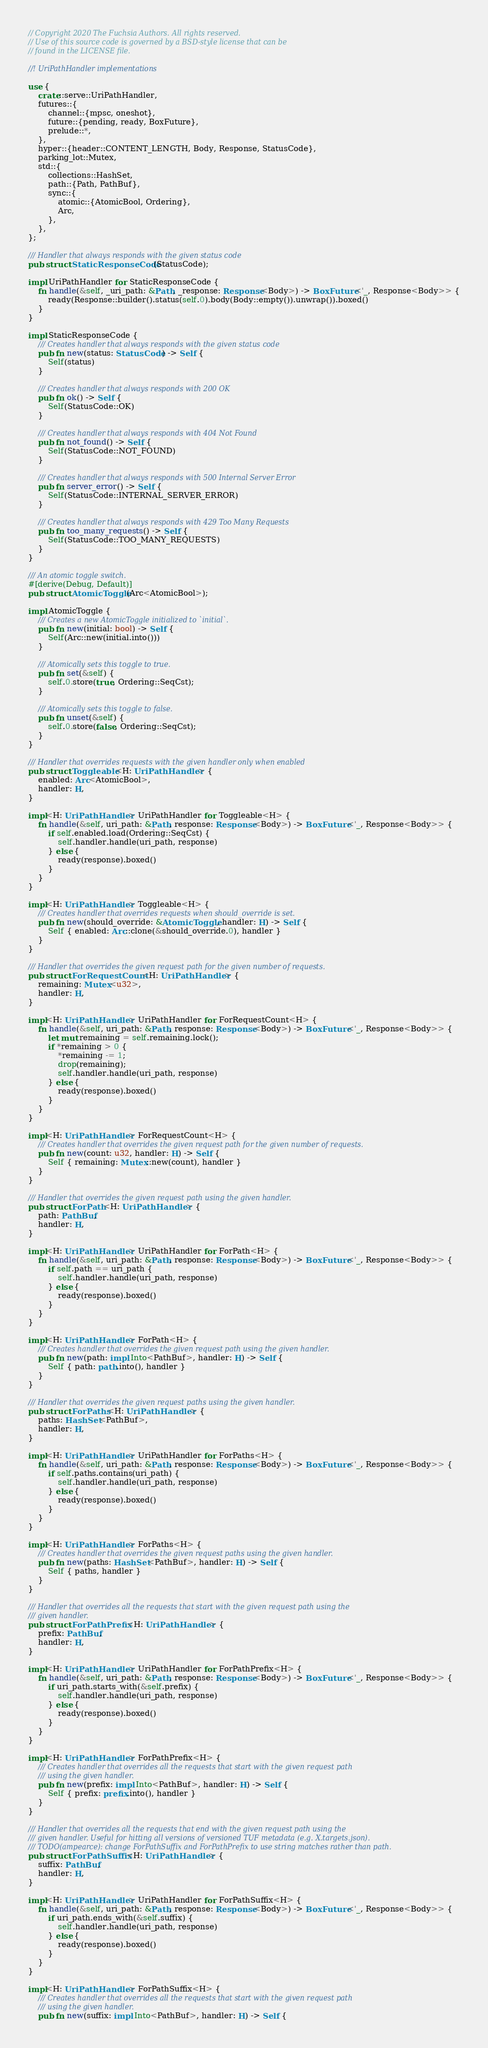Convert code to text. <code><loc_0><loc_0><loc_500><loc_500><_Rust_>// Copyright 2020 The Fuchsia Authors. All rights reserved.
// Use of this source code is governed by a BSD-style license that can be
// found in the LICENSE file.

//! UriPathHandler implementations

use {
    crate::serve::UriPathHandler,
    futures::{
        channel::{mpsc, oneshot},
        future::{pending, ready, BoxFuture},
        prelude::*,
    },
    hyper::{header::CONTENT_LENGTH, Body, Response, StatusCode},
    parking_lot::Mutex,
    std::{
        collections::HashSet,
        path::{Path, PathBuf},
        sync::{
            atomic::{AtomicBool, Ordering},
            Arc,
        },
    },
};

/// Handler that always responds with the given status code
pub struct StaticResponseCode(StatusCode);

impl UriPathHandler for StaticResponseCode {
    fn handle(&self, _uri_path: &Path, _response: Response<Body>) -> BoxFuture<'_, Response<Body>> {
        ready(Response::builder().status(self.0).body(Body::empty()).unwrap()).boxed()
    }
}

impl StaticResponseCode {
    /// Creates handler that always responds with the given status code
    pub fn new(status: StatusCode) -> Self {
        Self(status)
    }

    /// Creates handler that always responds with 200 OK
    pub fn ok() -> Self {
        Self(StatusCode::OK)
    }

    /// Creates handler that always responds with 404 Not Found
    pub fn not_found() -> Self {
        Self(StatusCode::NOT_FOUND)
    }

    /// Creates handler that always responds with 500 Internal Server Error
    pub fn server_error() -> Self {
        Self(StatusCode::INTERNAL_SERVER_ERROR)
    }

    /// Creates handler that always responds with 429 Too Many Requests
    pub fn too_many_requests() -> Self {
        Self(StatusCode::TOO_MANY_REQUESTS)
    }
}

/// An atomic toggle switch.
#[derive(Debug, Default)]
pub struct AtomicToggle(Arc<AtomicBool>);

impl AtomicToggle {
    /// Creates a new AtomicToggle initialized to `initial`.
    pub fn new(initial: bool) -> Self {
        Self(Arc::new(initial.into()))
    }

    /// Atomically sets this toggle to true.
    pub fn set(&self) {
        self.0.store(true, Ordering::SeqCst);
    }

    /// Atomically sets this toggle to false.
    pub fn unset(&self) {
        self.0.store(false, Ordering::SeqCst);
    }
}

/// Handler that overrides requests with the given handler only when enabled
pub struct Toggleable<H: UriPathHandler> {
    enabled: Arc<AtomicBool>,
    handler: H,
}

impl<H: UriPathHandler> UriPathHandler for Toggleable<H> {
    fn handle(&self, uri_path: &Path, response: Response<Body>) -> BoxFuture<'_, Response<Body>> {
        if self.enabled.load(Ordering::SeqCst) {
            self.handler.handle(uri_path, response)
        } else {
            ready(response).boxed()
        }
    }
}

impl<H: UriPathHandler> Toggleable<H> {
    /// Creates handler that overrides requests when should_override is set.
    pub fn new(should_override: &AtomicToggle, handler: H) -> Self {
        Self { enabled: Arc::clone(&should_override.0), handler }
    }
}

/// Handler that overrides the given request path for the given number of requests.
pub struct ForRequestCount<H: UriPathHandler> {
    remaining: Mutex<u32>,
    handler: H,
}

impl<H: UriPathHandler> UriPathHandler for ForRequestCount<H> {
    fn handle(&self, uri_path: &Path, response: Response<Body>) -> BoxFuture<'_, Response<Body>> {
        let mut remaining = self.remaining.lock();
        if *remaining > 0 {
            *remaining -= 1;
            drop(remaining);
            self.handler.handle(uri_path, response)
        } else {
            ready(response).boxed()
        }
    }
}

impl<H: UriPathHandler> ForRequestCount<H> {
    /// Creates handler that overrides the given request path for the given number of requests.
    pub fn new(count: u32, handler: H) -> Self {
        Self { remaining: Mutex::new(count), handler }
    }
}

/// Handler that overrides the given request path using the given handler.
pub struct ForPath<H: UriPathHandler> {
    path: PathBuf,
    handler: H,
}

impl<H: UriPathHandler> UriPathHandler for ForPath<H> {
    fn handle(&self, uri_path: &Path, response: Response<Body>) -> BoxFuture<'_, Response<Body>> {
        if self.path == uri_path {
            self.handler.handle(uri_path, response)
        } else {
            ready(response).boxed()
        }
    }
}

impl<H: UriPathHandler> ForPath<H> {
    /// Creates handler that overrides the given request path using the given handler.
    pub fn new(path: impl Into<PathBuf>, handler: H) -> Self {
        Self { path: path.into(), handler }
    }
}

/// Handler that overrides the given request paths using the given handler.
pub struct ForPaths<H: UriPathHandler> {
    paths: HashSet<PathBuf>,
    handler: H,
}

impl<H: UriPathHandler> UriPathHandler for ForPaths<H> {
    fn handle(&self, uri_path: &Path, response: Response<Body>) -> BoxFuture<'_, Response<Body>> {
        if self.paths.contains(uri_path) {
            self.handler.handle(uri_path, response)
        } else {
            ready(response).boxed()
        }
    }
}

impl<H: UriPathHandler> ForPaths<H> {
    /// Creates handler that overrides the given request paths using the given handler.
    pub fn new(paths: HashSet<PathBuf>, handler: H) -> Self {
        Self { paths, handler }
    }
}

/// Handler that overrides all the requests that start with the given request path using the
/// given handler.
pub struct ForPathPrefix<H: UriPathHandler> {
    prefix: PathBuf,
    handler: H,
}

impl<H: UriPathHandler> UriPathHandler for ForPathPrefix<H> {
    fn handle(&self, uri_path: &Path, response: Response<Body>) -> BoxFuture<'_, Response<Body>> {
        if uri_path.starts_with(&self.prefix) {
            self.handler.handle(uri_path, response)
        } else {
            ready(response).boxed()
        }
    }
}

impl<H: UriPathHandler> ForPathPrefix<H> {
    /// Creates handler that overrides all the requests that start with the given request path
    /// using the given handler.
    pub fn new(prefix: impl Into<PathBuf>, handler: H) -> Self {
        Self { prefix: prefix.into(), handler }
    }
}

/// Handler that overrides all the requests that end with the given request path using the
/// given handler. Useful for hitting all versions of versioned TUF metadata (e.g. X.targets.json).
/// TODO(ampearce): change ForPathSuffix and ForPathPrefix to use string matches rather than path.
pub struct ForPathSuffix<H: UriPathHandler> {
    suffix: PathBuf,
    handler: H,
}

impl<H: UriPathHandler> UriPathHandler for ForPathSuffix<H> {
    fn handle(&self, uri_path: &Path, response: Response<Body>) -> BoxFuture<'_, Response<Body>> {
        if uri_path.ends_with(&self.suffix) {
            self.handler.handle(uri_path, response)
        } else {
            ready(response).boxed()
        }
    }
}

impl<H: UriPathHandler> ForPathSuffix<H> {
    /// Creates handler that overrides all the requests that start with the given request path
    /// using the given handler.
    pub fn new(suffix: impl Into<PathBuf>, handler: H) -> Self {</code> 